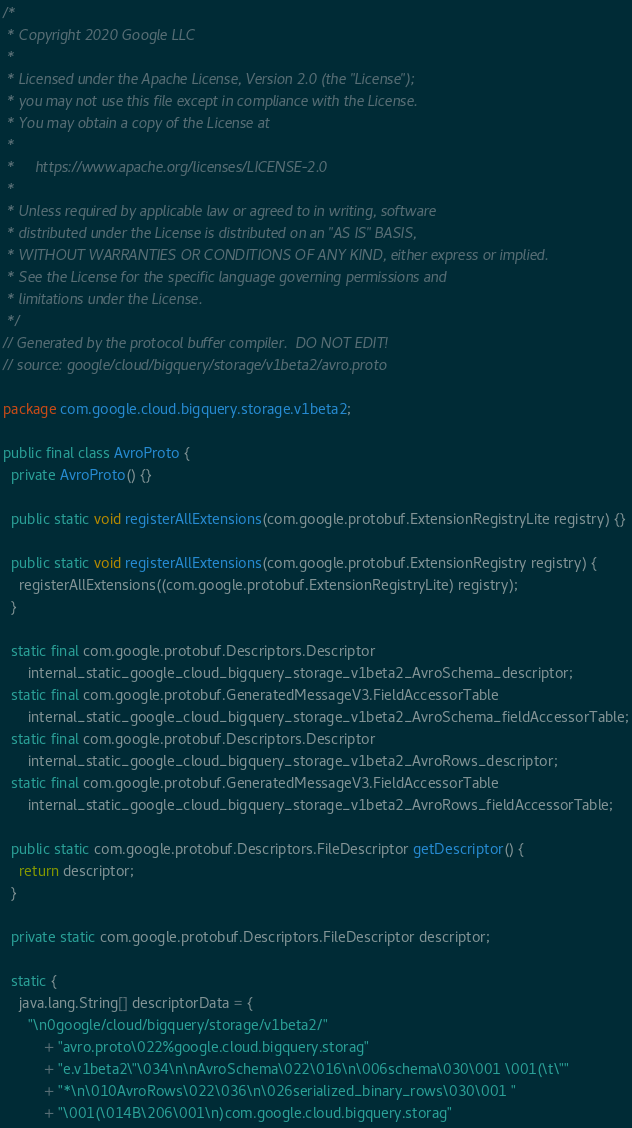Convert code to text. <code><loc_0><loc_0><loc_500><loc_500><_Java_>/*
 * Copyright 2020 Google LLC
 *
 * Licensed under the Apache License, Version 2.0 (the "License");
 * you may not use this file except in compliance with the License.
 * You may obtain a copy of the License at
 *
 *     https://www.apache.org/licenses/LICENSE-2.0
 *
 * Unless required by applicable law or agreed to in writing, software
 * distributed under the License is distributed on an "AS IS" BASIS,
 * WITHOUT WARRANTIES OR CONDITIONS OF ANY KIND, either express or implied.
 * See the License for the specific language governing permissions and
 * limitations under the License.
 */
// Generated by the protocol buffer compiler.  DO NOT EDIT!
// source: google/cloud/bigquery/storage/v1beta2/avro.proto

package com.google.cloud.bigquery.storage.v1beta2;

public final class AvroProto {
  private AvroProto() {}

  public static void registerAllExtensions(com.google.protobuf.ExtensionRegistryLite registry) {}

  public static void registerAllExtensions(com.google.protobuf.ExtensionRegistry registry) {
    registerAllExtensions((com.google.protobuf.ExtensionRegistryLite) registry);
  }

  static final com.google.protobuf.Descriptors.Descriptor
      internal_static_google_cloud_bigquery_storage_v1beta2_AvroSchema_descriptor;
  static final com.google.protobuf.GeneratedMessageV3.FieldAccessorTable
      internal_static_google_cloud_bigquery_storage_v1beta2_AvroSchema_fieldAccessorTable;
  static final com.google.protobuf.Descriptors.Descriptor
      internal_static_google_cloud_bigquery_storage_v1beta2_AvroRows_descriptor;
  static final com.google.protobuf.GeneratedMessageV3.FieldAccessorTable
      internal_static_google_cloud_bigquery_storage_v1beta2_AvroRows_fieldAccessorTable;

  public static com.google.protobuf.Descriptors.FileDescriptor getDescriptor() {
    return descriptor;
  }

  private static com.google.protobuf.Descriptors.FileDescriptor descriptor;

  static {
    java.lang.String[] descriptorData = {
      "\n0google/cloud/bigquery/storage/v1beta2/"
          + "avro.proto\022%google.cloud.bigquery.storag"
          + "e.v1beta2\"\034\n\nAvroSchema\022\016\n\006schema\030\001 \001(\t\""
          + "*\n\010AvroRows\022\036\n\026serialized_binary_rows\030\001 "
          + "\001(\014B\206\001\n)com.google.cloud.bigquery.storag"</code> 